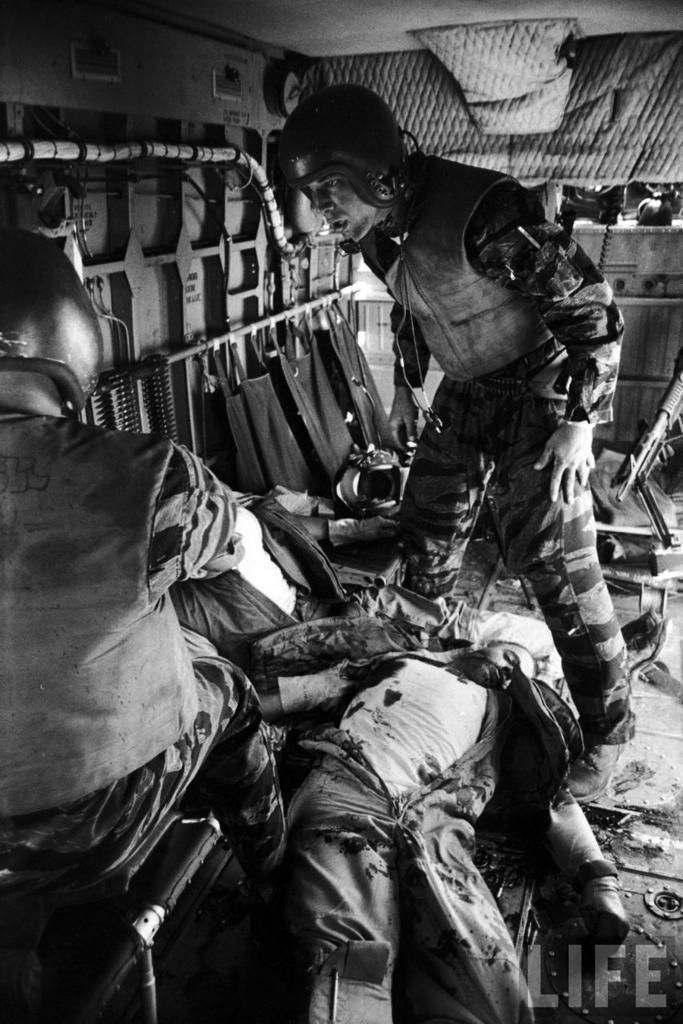In one or two sentences, can you explain what this image depicts? In the center of the image we can see a man standing. On the left there is a person sitting. At the bottom we can see a man lying. In the background there is a wall and we can see some equipment. on the right there is a rifle. 